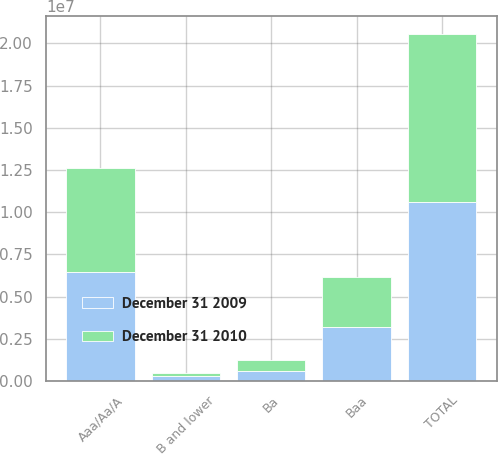Convert chart to OTSL. <chart><loc_0><loc_0><loc_500><loc_500><stacked_bar_chart><ecel><fcel>Aaa/Aa/A<fcel>Baa<fcel>Ba<fcel>B and lower<fcel>TOTAL<nl><fcel>December 31 2009<fcel>6.48821e+06<fcel>3.22722e+06<fcel>618465<fcel>278663<fcel>1.06126e+07<nl><fcel>December 31 2010<fcel>6.15284e+06<fcel>2.95396e+06<fcel>647321<fcel>212645<fcel>9.96677e+06<nl></chart> 